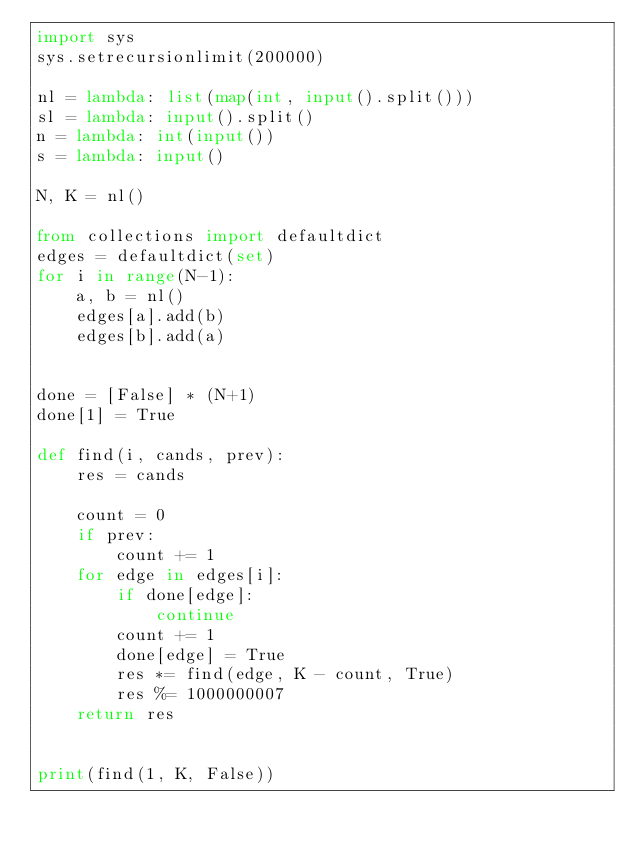<code> <loc_0><loc_0><loc_500><loc_500><_Python_>import sys
sys.setrecursionlimit(200000)

nl = lambda: list(map(int, input().split()))
sl = lambda: input().split()
n = lambda: int(input())
s = lambda: input()

N, K = nl()

from collections import defaultdict
edges = defaultdict(set)
for i in range(N-1):
    a, b = nl()
    edges[a].add(b)
    edges[b].add(a)


done = [False] * (N+1)
done[1] = True

def find(i, cands, prev):
    res = cands

    count = 0
    if prev:
        count += 1
    for edge in edges[i]:
        if done[edge]:
            continue
        count += 1
        done[edge] = True
        res *= find(edge, K - count, True)
        res %= 1000000007
    return res


print(find(1, K, False))

</code> 